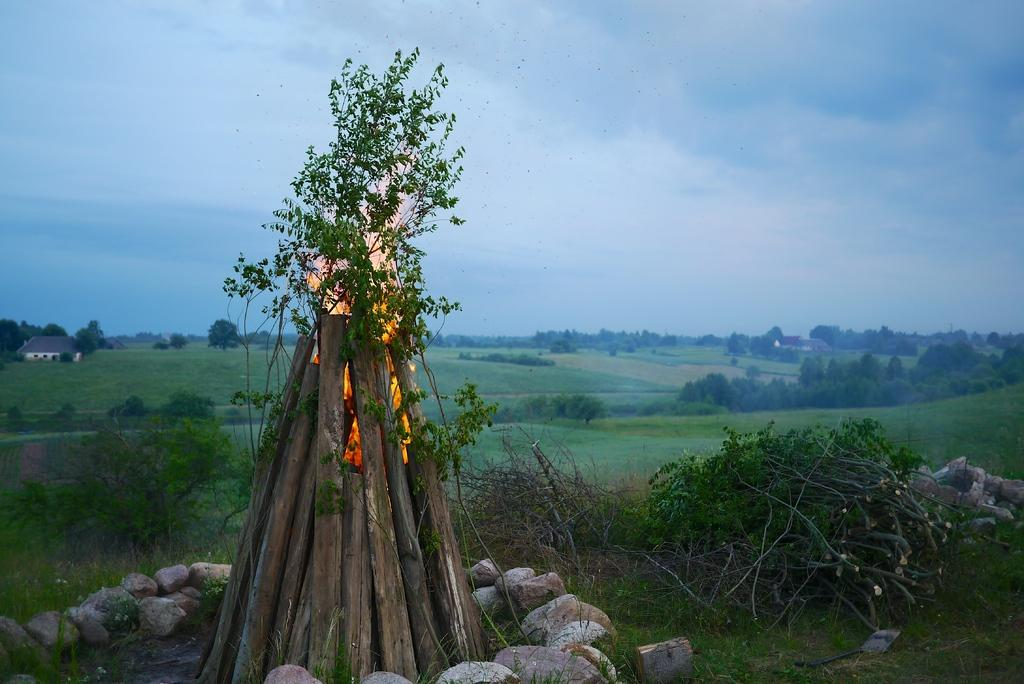What objects are present in the image that are made of wood? There are wooden logs in the image. What is happening to the wooden logs? There is on the wooden logs. What can be seen in the background of the image? There are trees in the background of the image. What is the color of the trees? The trees are green. What colors are visible in the sky in the image? The sky is blue and white. What type of insurance policy is being discussed in the image? There is no discussion of insurance in the image; it features wooden logs on fire with green trees in the background and a blue and white sky. How many kites can be seen flying in the image? There are no kites present in the image. 